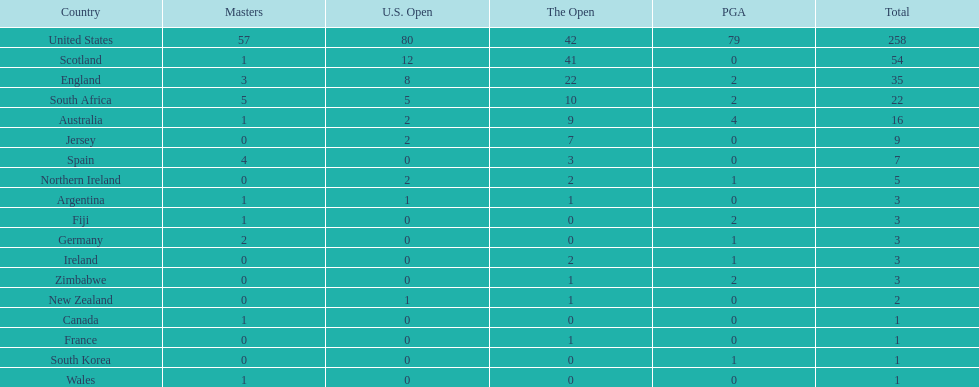How many countries have produced the same number of championship golfers as canada? 3. 